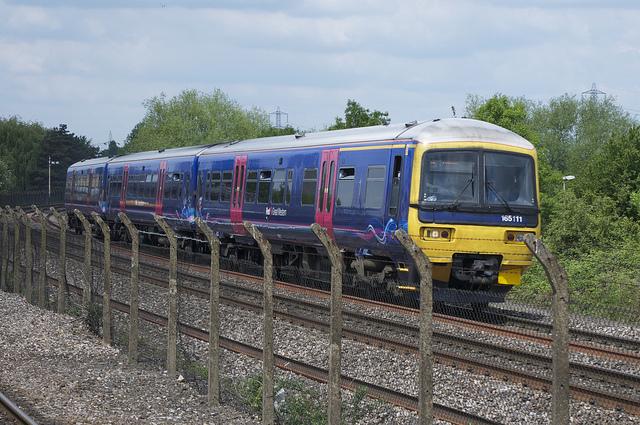What is the fence made out of?
Give a very brief answer. Metal. Is there a train?
Short answer required. Yes. What number is on the train?
Write a very short answer. 165111. What color is the train door?
Quick response, please. Red. Is this train moving?
Concise answer only. Yes. What color is the door?
Be succinct. Red. What color is the train?
Answer briefly. Blue. What color are the doors of the train?
Short answer required. Red. Did she get off at her stop?
Be succinct. No. Does this train go fast?
Keep it brief. Yes. What is the color on the front on the train?
Write a very short answer. Yellow. 